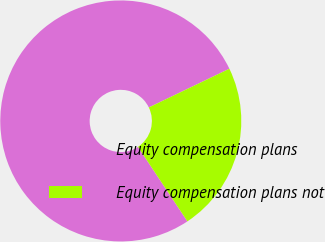Convert chart to OTSL. <chart><loc_0><loc_0><loc_500><loc_500><pie_chart><fcel>Equity compensation plans<fcel>Equity compensation plans not<nl><fcel>77.19%<fcel>22.81%<nl></chart> 